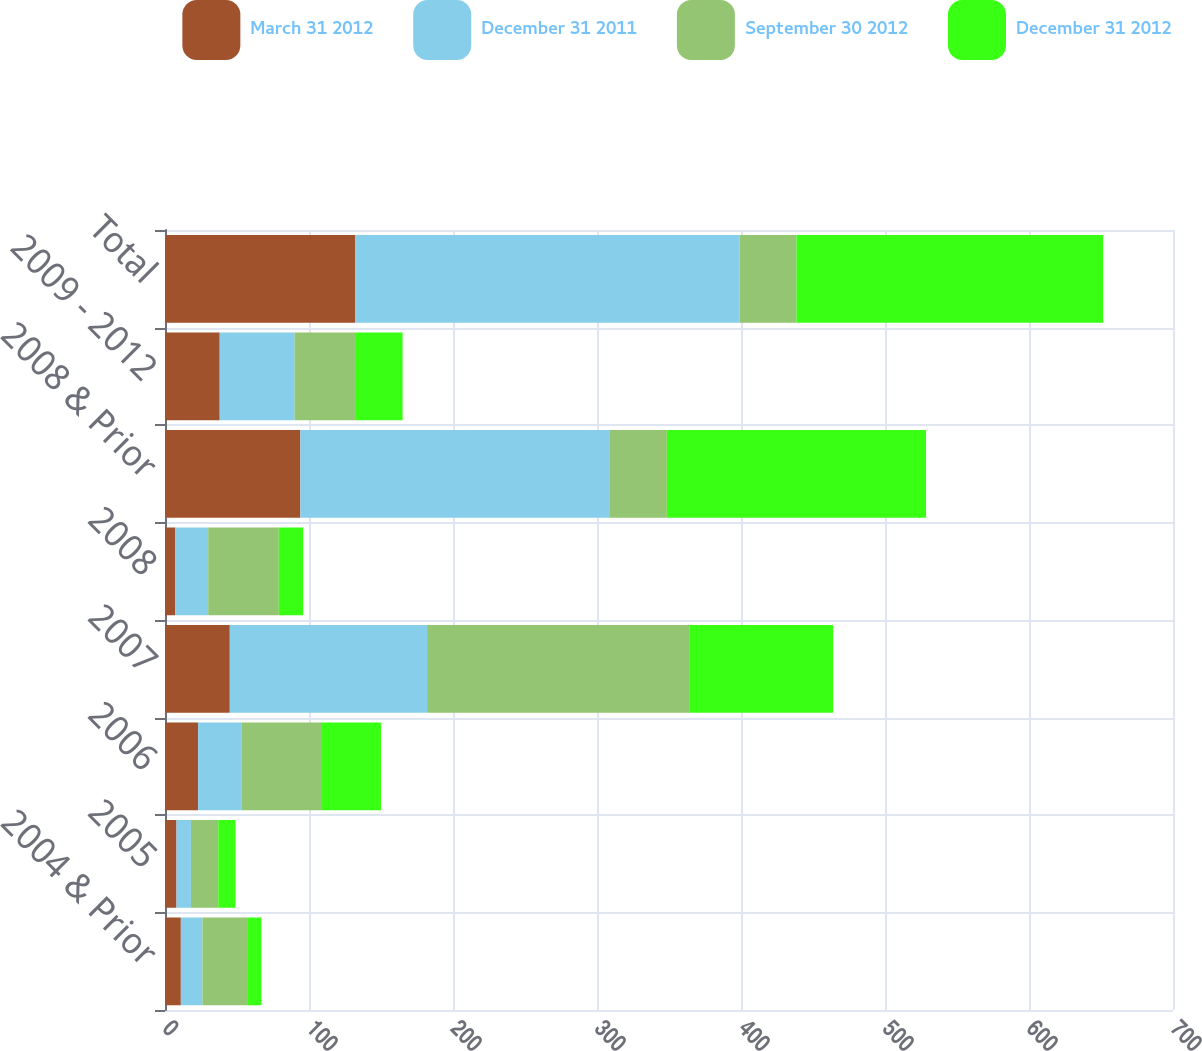Convert chart to OTSL. <chart><loc_0><loc_0><loc_500><loc_500><stacked_bar_chart><ecel><fcel>2004 & Prior<fcel>2005<fcel>2006<fcel>2007<fcel>2008<fcel>2008 & Prior<fcel>2009 - 2012<fcel>Total<nl><fcel>March 31 2012<fcel>11<fcel>8<fcel>23<fcel>45<fcel>7<fcel>94<fcel>38<fcel>132<nl><fcel>December 31 2011<fcel>15<fcel>10<fcel>30<fcel>137<fcel>23<fcel>215<fcel>52<fcel>267<nl><fcel>September 30 2012<fcel>31<fcel>19<fcel>56<fcel>182<fcel>49<fcel>39.5<fcel>42<fcel>39.5<nl><fcel>December 31 2012<fcel>10<fcel>12<fcel>41<fcel>100<fcel>17<fcel>180<fcel>33<fcel>213<nl></chart> 